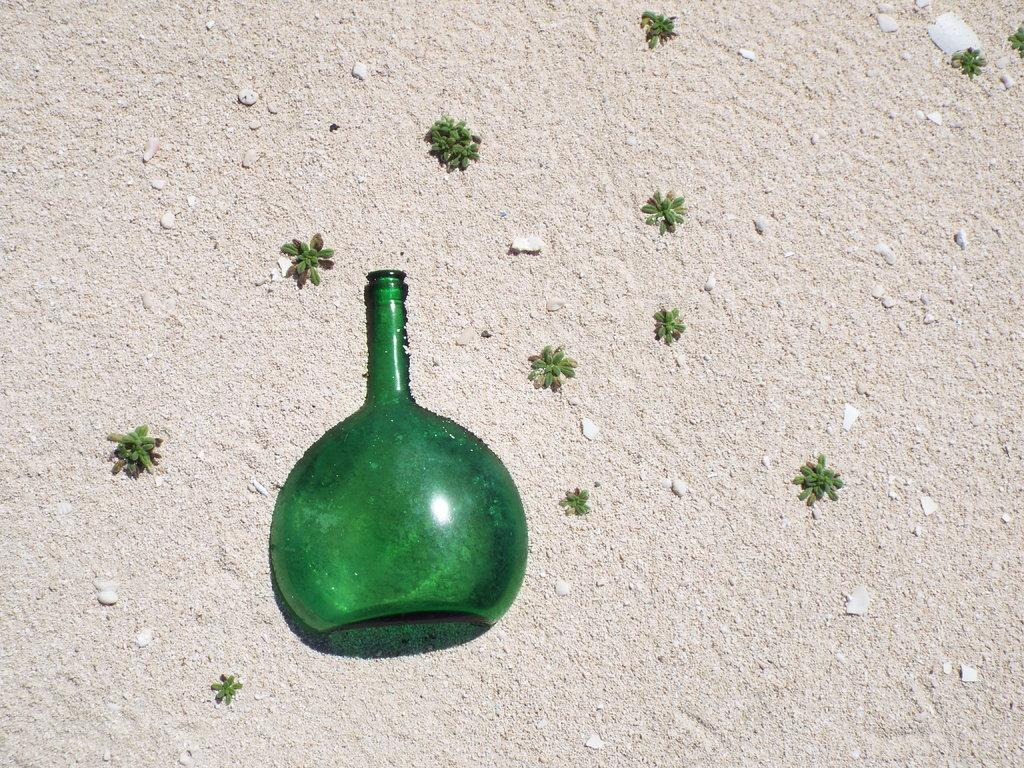What type of bottle is in the image? There is a green glass bottle in the image. Where is the bottle located? The bottle is on the ground. What else can be seen in the image besides the bottle? There are plants, sand, and stones visible in the image. How many snakes are slithering around the green glass bottle in the image? There are no snakes present in the image; it only features a green glass bottle, plants, sand, and stones. 